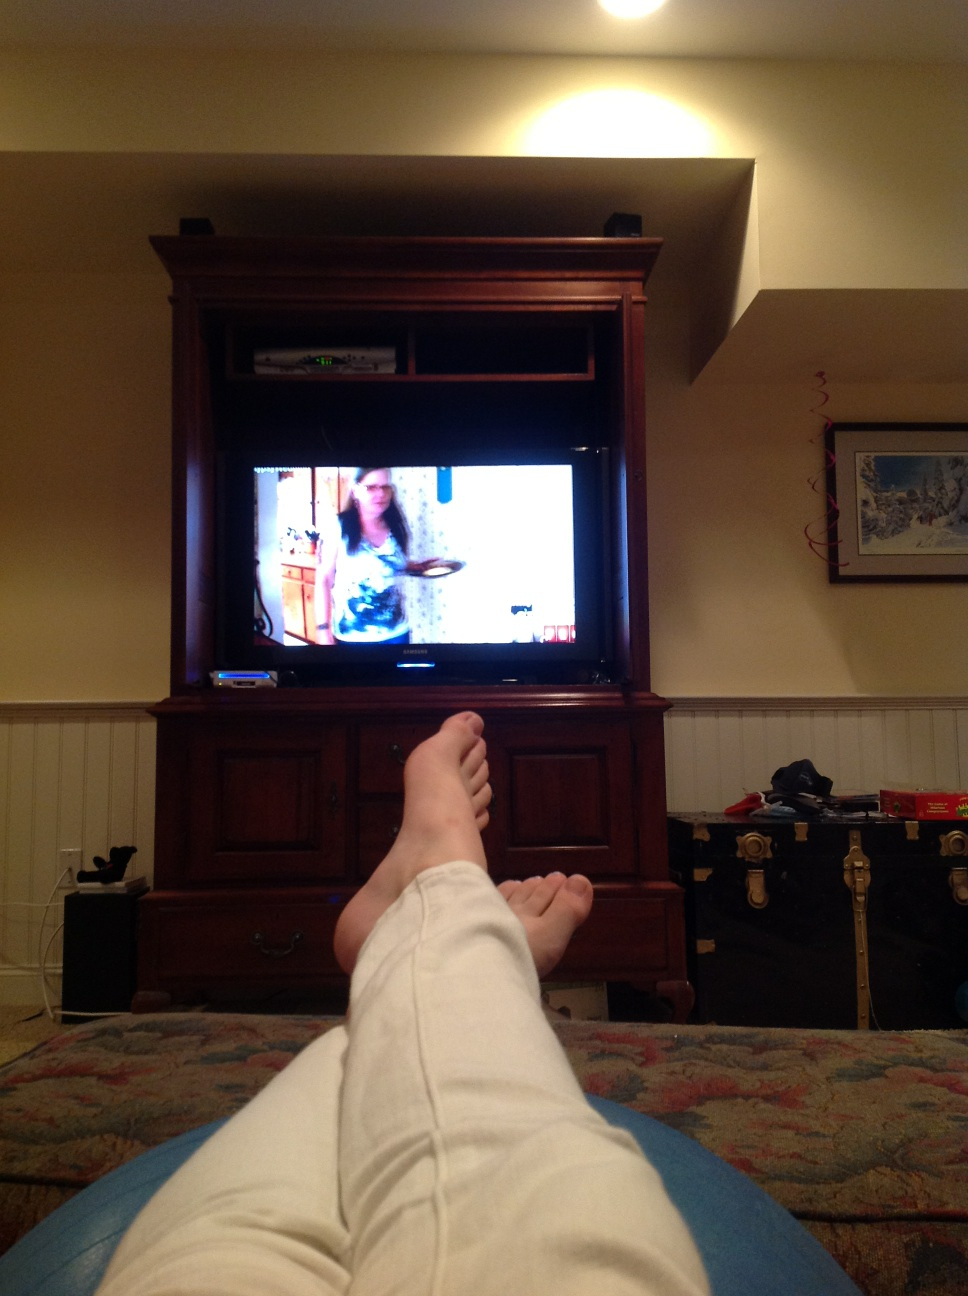How many toes does this person have?  from Vizwiz 10 